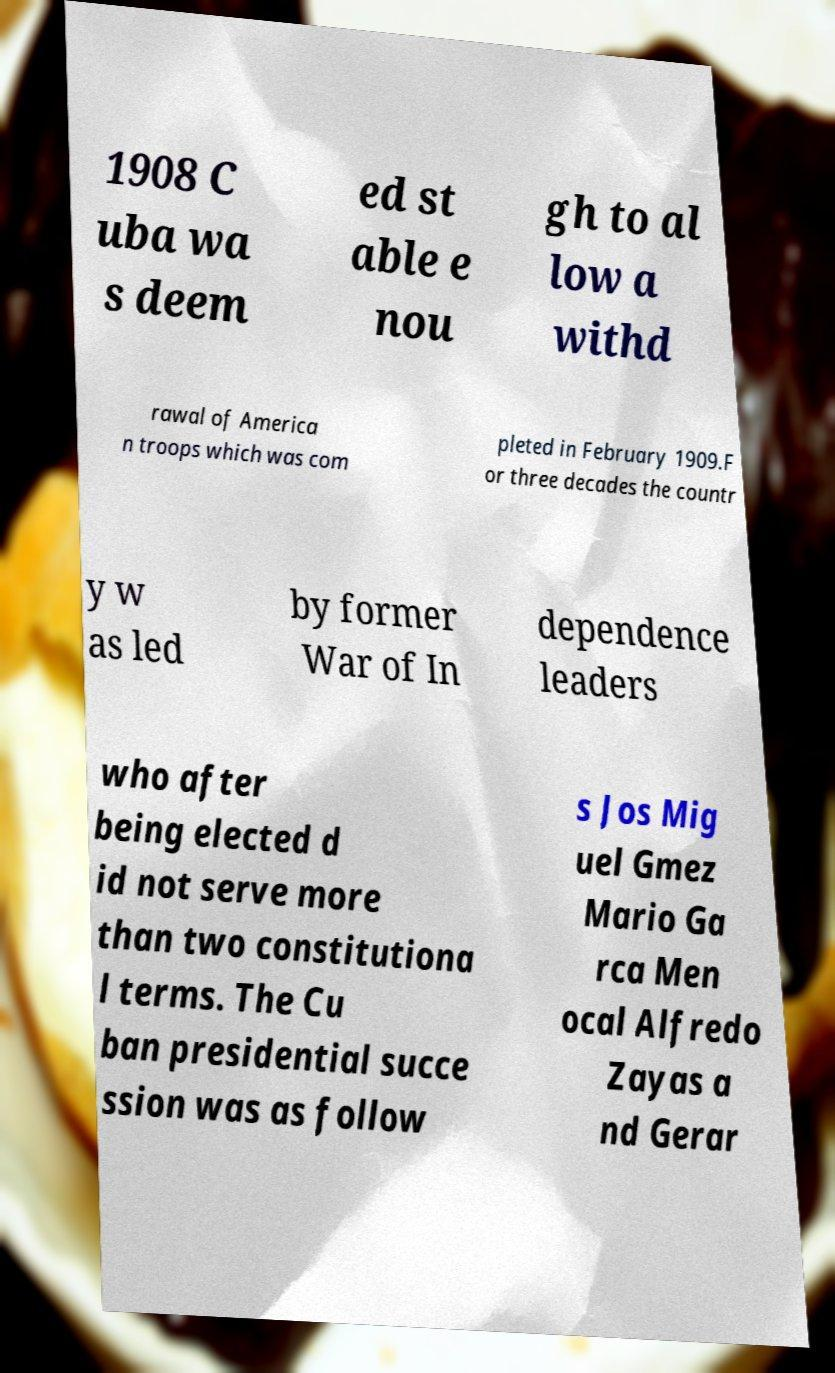Can you read and provide the text displayed in the image?This photo seems to have some interesting text. Can you extract and type it out for me? 1908 C uba wa s deem ed st able e nou gh to al low a withd rawal of America n troops which was com pleted in February 1909.F or three decades the countr y w as led by former War of In dependence leaders who after being elected d id not serve more than two constitutiona l terms. The Cu ban presidential succe ssion was as follow s Jos Mig uel Gmez Mario Ga rca Men ocal Alfredo Zayas a nd Gerar 